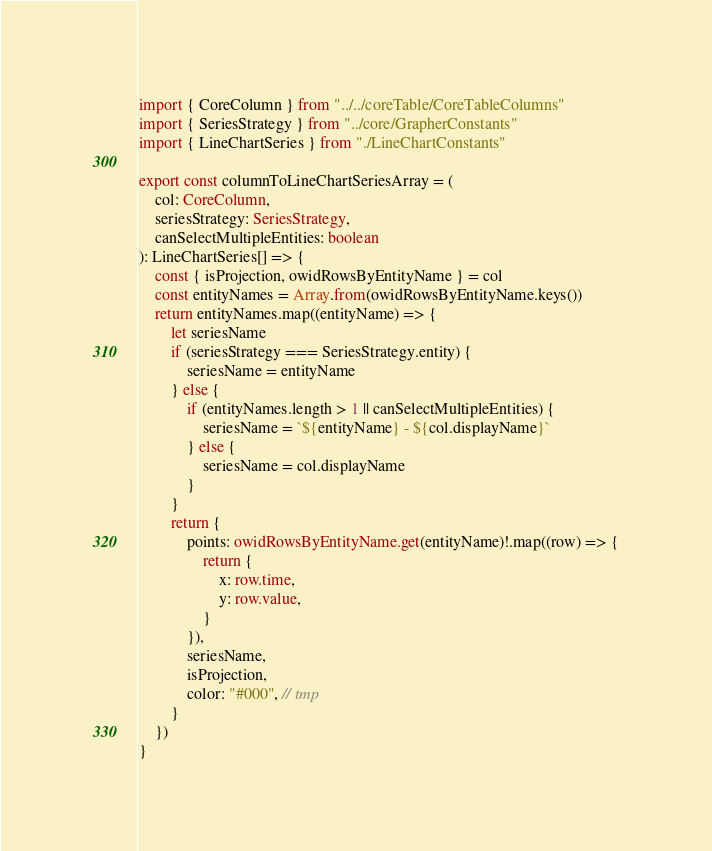Convert code to text. <code><loc_0><loc_0><loc_500><loc_500><_TypeScript_>import { CoreColumn } from "../../coreTable/CoreTableColumns"
import { SeriesStrategy } from "../core/GrapherConstants"
import { LineChartSeries } from "./LineChartConstants"

export const columnToLineChartSeriesArray = (
    col: CoreColumn,
    seriesStrategy: SeriesStrategy,
    canSelectMultipleEntities: boolean
): LineChartSeries[] => {
    const { isProjection, owidRowsByEntityName } = col
    const entityNames = Array.from(owidRowsByEntityName.keys())
    return entityNames.map((entityName) => {
        let seriesName
        if (seriesStrategy === SeriesStrategy.entity) {
            seriesName = entityName
        } else {
            if (entityNames.length > 1 || canSelectMultipleEntities) {
                seriesName = `${entityName} - ${col.displayName}`
            } else {
                seriesName = col.displayName
            }
        }
        return {
            points: owidRowsByEntityName.get(entityName)!.map((row) => {
                return {
                    x: row.time,
                    y: row.value,
                }
            }),
            seriesName,
            isProjection,
            color: "#000", // tmp
        }
    })
}
</code> 